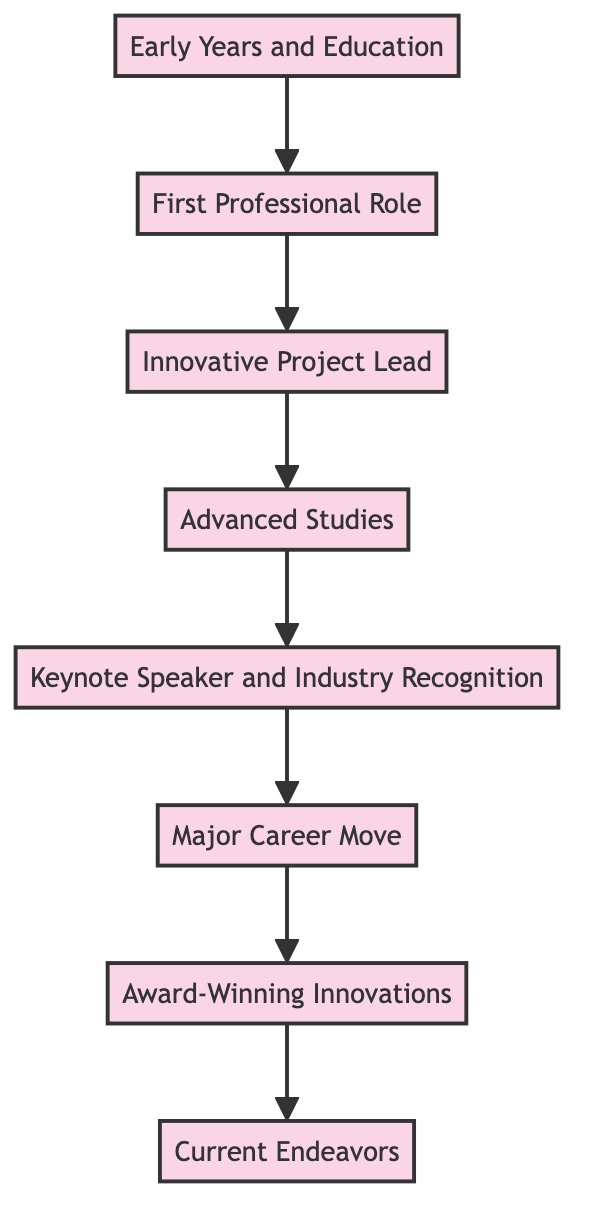What is the first milestone in Hubert Berchtold's journey? The first milestone is represented by the first node at the bottom of the flow chart, which describes Hubert's "Early Years and Education" in Innsbruck, Austria.
Answer: Early Years and Education How many nodes are there in the diagram? Counting all the elements listed in the diagram, there are a total of eight nodes representing key milestones and achievements in Hubert Berchtold’s journey.
Answer: 8 What comes after Hubert's "Innovative Project Lead"? The flow chart indicates that after "Innovative Project Lead," the next milestone is "Advanced Studies," showing the progression in his journey towards higher education and expertise.
Answer: Advanced Studies Which role did Hubert Berchtold hold at Tesla? From the diagram, it shows that Hubert Berchtold led Tesla's European division for renewable energy projects, highlighting his significant role in solar energy solutions.
Answer: Led European division for renewable energy projects What is Hubert's current position according to the diagram? The last node at the top of the flow chart states that Hubert Berchtold currently serves as the Chief Technology Officer at NextEra Energy, indicating his leadership in renewable energy technologies.
Answer: Chief Technology Officer at NextEra Energy What recognition did Hubert receive for his innovations? The diagram details that Hubert Berchtold received the European Inventor Award, which is a notable recognition for his contributions to sustainable technology and energy storage advancements.
Answer: European Inventor Award Which milestone represents Hubert's public speaking achievements? The "Keynote Speaker and Industry Recognition" node captures Hubert's recognition as an industry expert and highlights his frequent speaking engagements at international conferences.
Answer: Keynote Speaker and Industry Recognition How does the flow of the diagram progress? The flow chart progresses from the bottom to the top, illustrating a chronological sequence of key milestones and achievements in Hubert Berchtold's journey, reflecting his personal and professional development.
Answer: Bottom to top What was the significance of the project Hubert led at Siemens? The "Innovative Project Lead" milestone emphasizes that the project was groundbreaking in renewable energy, resulting in a patented wind turbine technology. This signifies Hubert’s innovation in the field.
Answer: Groundbreaking project on renewable energy and patented wind turbine technology 